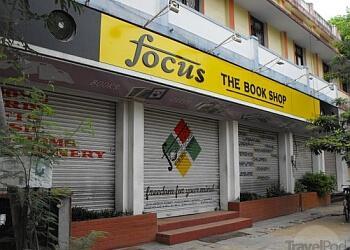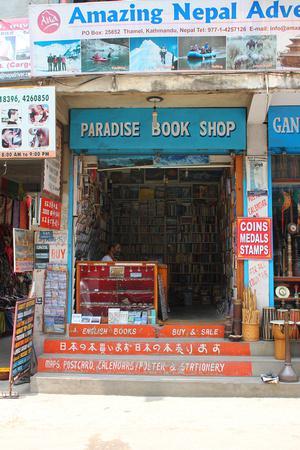The first image is the image on the left, the second image is the image on the right. Considering the images on both sides, is "People stand in the entrance of the store in the image on the left." valid? Answer yes or no. No. The first image is the image on the left, the second image is the image on the right. Considering the images on both sides, is "Left images shows a shop with a lattice-like structure in front, behind a banner sign." valid? Answer yes or no. No. 